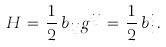Convert formula to latex. <formula><loc_0><loc_0><loc_500><loc_500>H \, = \, \frac { 1 } { 2 } \, b _ { i j } g ^ { i j } \, = \, \frac { 1 } { 2 } \, b _ { i } ^ { i } \, { . }</formula> 